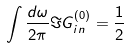<formula> <loc_0><loc_0><loc_500><loc_500>\int \frac { d \omega } { 2 \pi } \Im G _ { i n } ^ { ( 0 ) } = \frac { 1 } { 2 }</formula> 